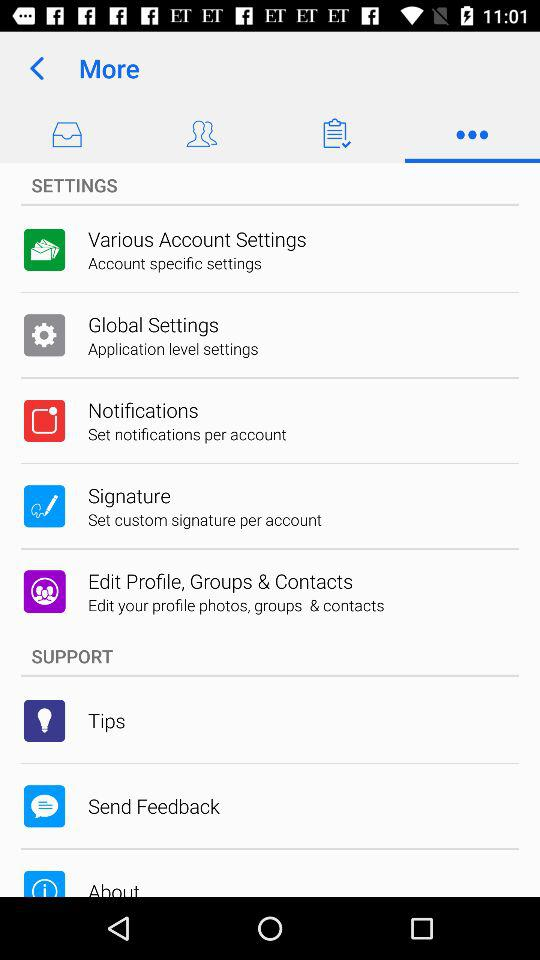Which tab is selected? The selected tab is "More". 